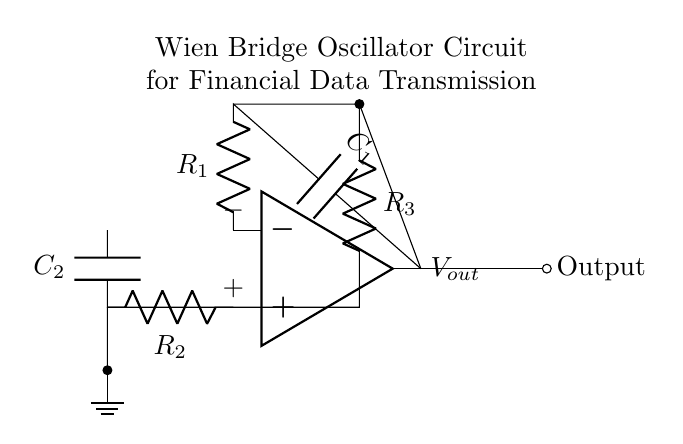What is the main operational component of this circuit? The main operational component is the operational amplifier, which is indicated at the center of the schematic. It is responsible for amplifying the voltage signals in the circuit.
Answer: operational amplifier How many resistors are in the oscillator circuit? The circuit contains three resistors, labeled as R1, R2, and R3. They are necessary for setting the frequency and gain of the oscillator.
Answer: three What kind of feedback is used in this circuit? The circuit uses positive and negative feedback. Positive feedback is indicated through the connection from the output back to the inverting input via R1 and C1, while negative feedback is through R2 and C2 to the non-inverting input.
Answer: positive and negative What is the purpose of the capacitors in the oscillator circuit? The capacitors, C1 and C2, are used to stabilize and set the frequency of the oscillator by determining the time constant in conjunction with the resistors. This affects the oscillation frequency of the circuit.
Answer: stabilize frequency Where is the output node of the oscillator circuit located? The output node is located at the op-amp's output, depicted as the rightmost node in the diagram and marked with "Output". It is where the generated frequency signal can be obtained.
Answer: rightmost node What effect does changing R1 have on the oscillator? Changing R1 alters the gain and can also affect the oscillation frequency, as it influences the feedback condition. A larger R1 can stabilize the circuit up to a certain frequency, beyond which oscillations may become unstable.
Answer: alters gain and frequency What is the significance of the ground in this circuit? The ground serves as a reference point for all voltages in the circuit, ensuring that the signal levels are consistent and aiding in the stability of the operational amplifier and overall circuit functionality.
Answer: reference point 